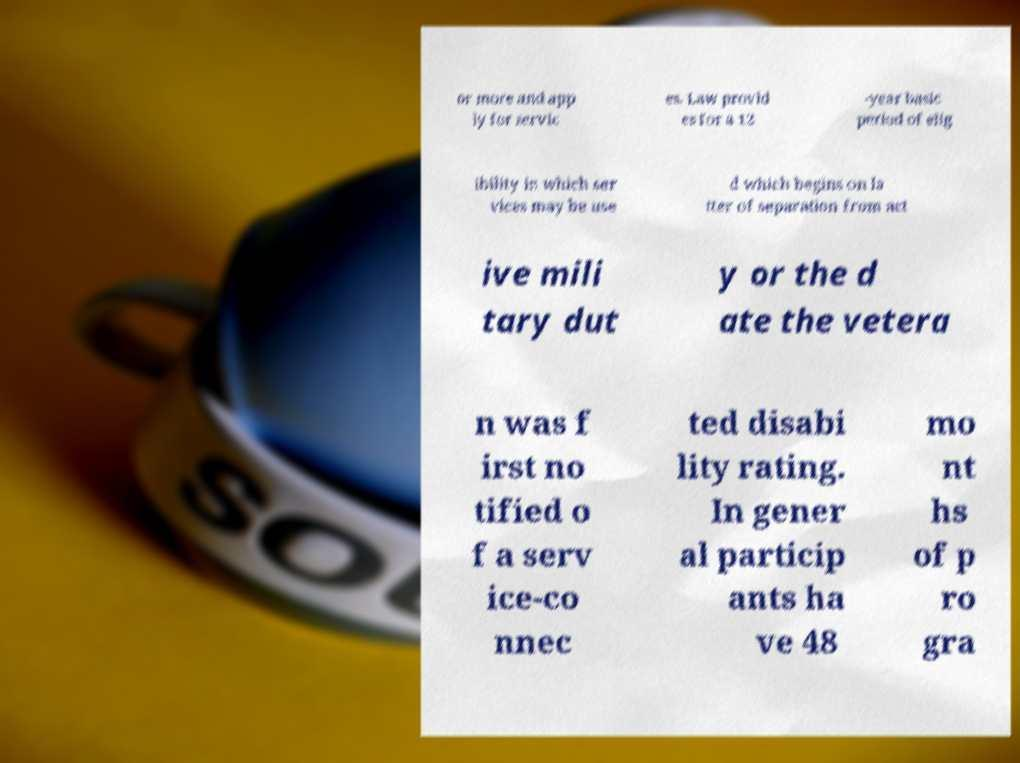Could you extract and type out the text from this image? or more and app ly for servic es. Law provid es for a 12 -year basic period of elig ibility in which ser vices may be use d which begins on la tter of separation from act ive mili tary dut y or the d ate the vetera n was f irst no tified o f a serv ice-co nnec ted disabi lity rating. In gener al particip ants ha ve 48 mo nt hs of p ro gra 